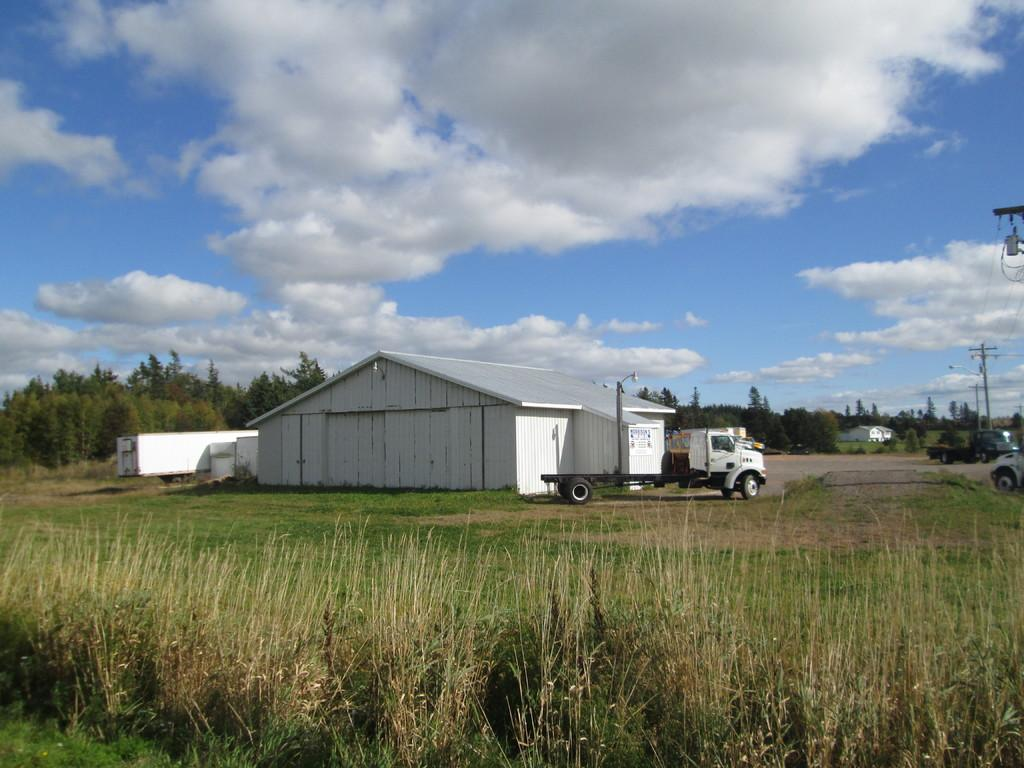What type of structure is present in the image? There is a small white shed house in the image. What vehicle is located beside the shed house? There is a white color van beside the shed house. What can be seen in the background of the image? There are trees visible behind the shed house and van. What type of ground is visible in the front side of the image? There is grass visible in the front side of the image. How do the ants show respect to the shed house in the image? There are no ants present in the image, so it is not possible to determine how they might show respect to the shed house. 